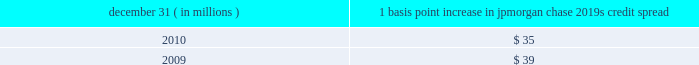Management 2019s discussion and analysis 144 jpmorgan chase & co./2010 annual report compared with $ 57 million for 2009 .
Decreases in cio and mort- gage banking var for 2010 were again driven by the decline in market volatility and position changes .
The decline in mortgage banking var at december 31 , 2010 , reflects management 2019s deci- sion to reduce risk given market volatility at the time .
The firm 2019s average ib and other var diversification benefit was $ 59 million or 37% ( 37 % ) of the sum for 2010 , compared with $ 82 million or 28% ( 28 % ) of the sum for 2009 .
The firm experienced an increase in the diversification benefit in 2010 as positions changed and correla- tions decreased .
In general , over the course of the year , var expo- sure can vary significantly as positions change , market volatility fluctuates and diversification benefits change .
Var back-testing the firm conducts daily back-testing of var against its market risk- related revenue , which is defined as the change in value of : princi- pal transactions revenue for ib and cio ( less private equity gains/losses and revenue from longer-term cio investments ) ; trading-related net interest income for ib , cio and mortgage bank- ing ; ib brokerage commissions , underwriting fees or other revenue ; revenue from syndicated lending facilities that the firm intends to distribute ; and mortgage fees and related income for the firm 2019s mortgage pipeline and warehouse loans , msrs , and all related hedges .
Daily firmwide market risk 2013related revenue excludes gains and losses from dva .
The following histogram illustrates the daily market risk 2013related gains and losses for ib , cio and mortgage banking positions for 2010 .
The chart shows that the firm posted market risk 2013related gains on 248 out of 261 days in this period , with 12 days exceeding $ 210 million .
The inset graph looks at those days on which the firm experienced losses and depicts the amount by which the 95% ( 95 % ) confidence-level var ex- ceeded the actual loss on each of those days .
During 2010 , losses were sustained on 13 days , none of which exceeded the var measure .
Daily ib and other market risk-related gains and losses ( 95% ( 95 % ) confidence-level var ) year ended december 31 , 2010 average daily revenue : $ 87 million $ in millions $ in millions daily ib and other var less market risk-related losses the table provides information about the gross sensitivity of dva to a one-basis-point increase in jpmorgan chase 2019s credit spreads .
This sensitivity represents the impact from a one-basis-point parallel shift in jpmorgan chase 2019s entire credit curve .
As credit curves do not typically move in a parallel fashion , the sensitivity multiplied by the change in spreads at a single maturity point may not be representative of the actual revenue recognized .
Debit valuation adjustment sensitivity 1 basis point increase in december 31 , ( in millions ) jpmorgan chase 2019s credit spread .

What was the change in average ib and other var diversification benefit in millions during 2010? 
Computations: (59 - 82)
Answer: -23.0. 